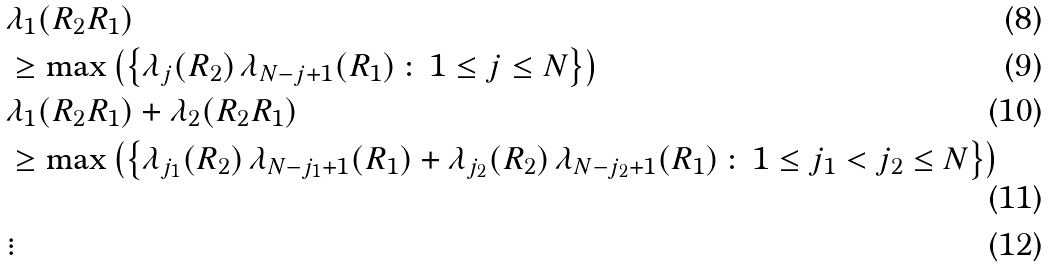Convert formula to latex. <formula><loc_0><loc_0><loc_500><loc_500>& \lambda _ { 1 } ( R _ { 2 } R _ { 1 } ) \\ & \geq \max \left ( \left \{ \lambda _ { j } ( R _ { 2 } ) \, \lambda _ { N - j + 1 } ( R _ { 1 } ) \, \colon \, 1 \leq j \leq N \right \} \right ) \\ & \lambda _ { 1 } ( R _ { 2 } R _ { 1 } ) + \lambda _ { 2 } ( R _ { 2 } R _ { 1 } ) \\ & \geq \max \left ( \left \{ \lambda _ { j _ { 1 } } ( R _ { 2 } ) \, \lambda _ { N - j _ { 1 } + 1 } ( R _ { 1 } ) + \lambda _ { j _ { 2 } } ( R _ { 2 } ) \, \lambda _ { N - j _ { 2 } + 1 } ( R _ { 1 } ) \, \colon \, 1 \leq j _ { 1 } < j _ { 2 } \leq N \right \} \right ) \\ & \vdots</formula> 